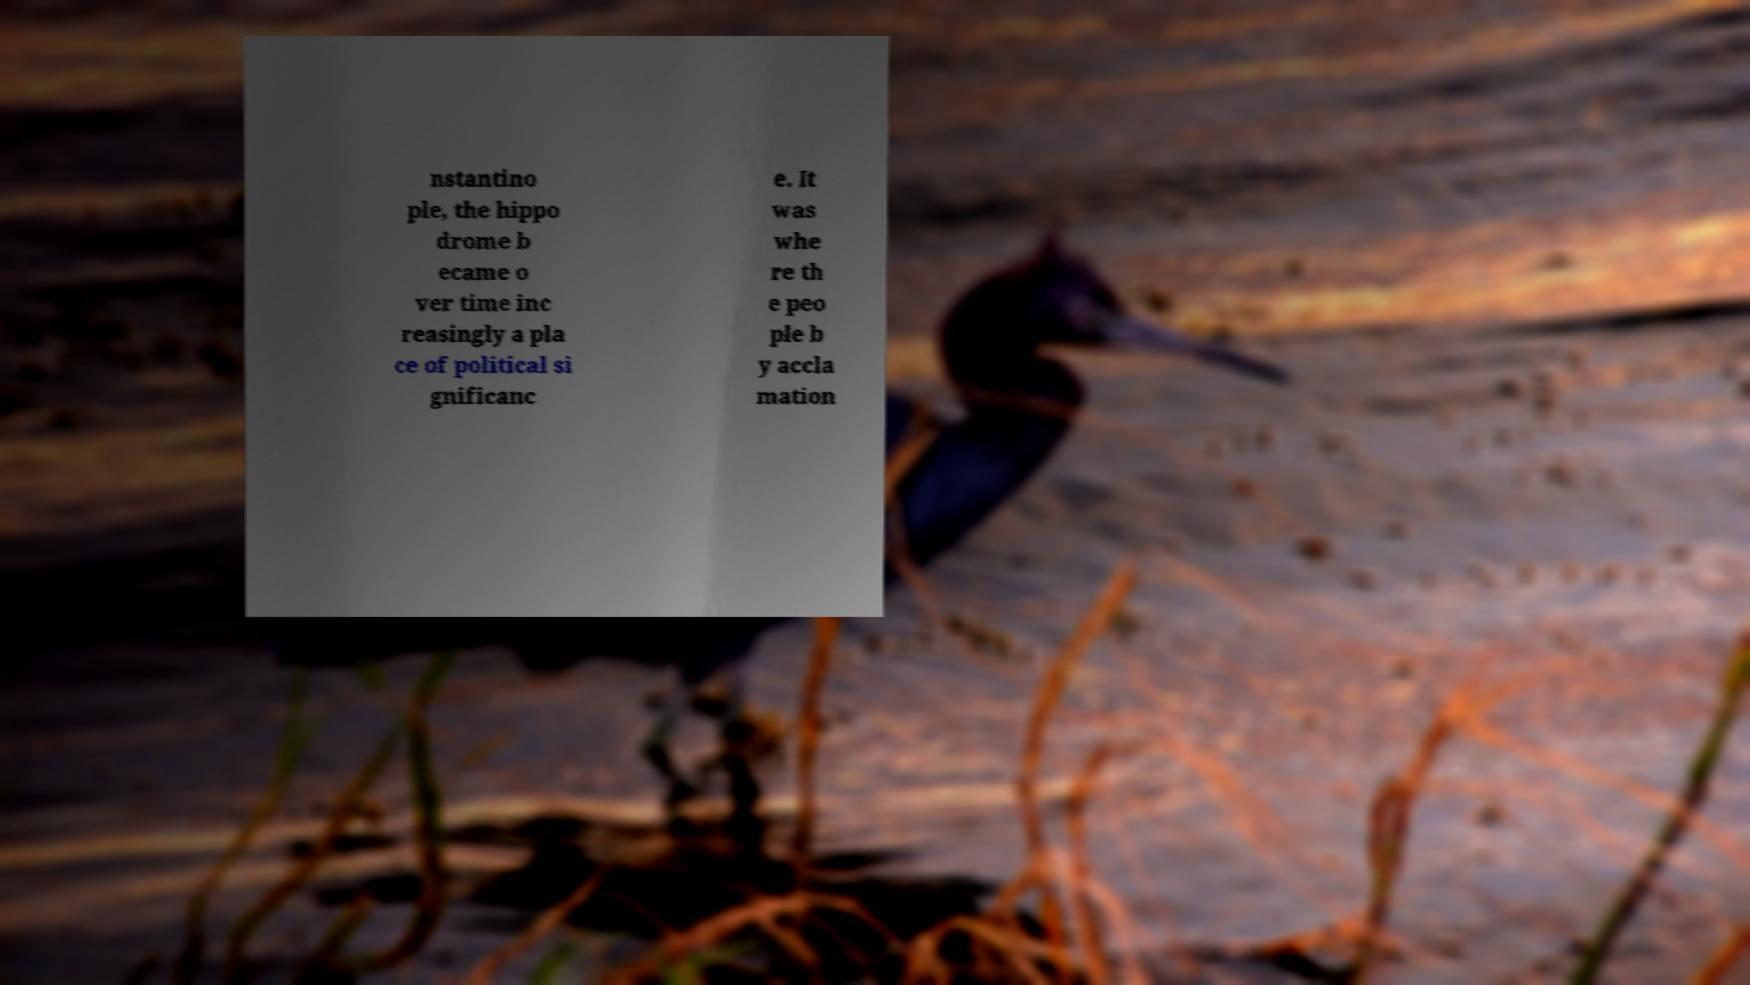Please read and relay the text visible in this image. What does it say? nstantino ple, the hippo drome b ecame o ver time inc reasingly a pla ce of political si gnificanc e. It was whe re th e peo ple b y accla mation 